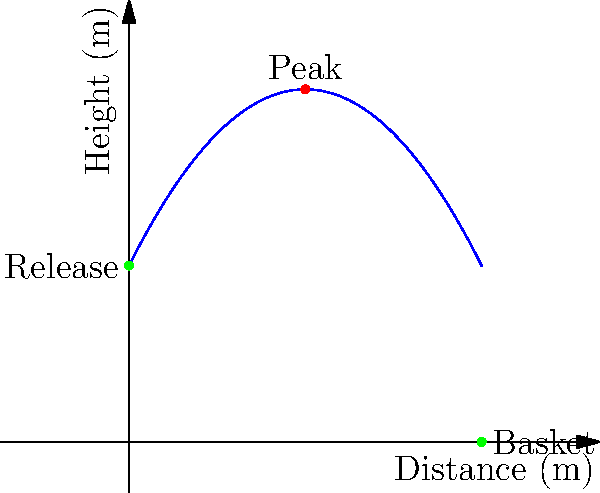As a former professional basketball player, you're analyzing the trajectory of a shot. The path of the ball can be modeled by the quadratic function $h(x) = -0.2x^2 + 2x + 5$, where $h$ is the height in meters and $x$ is the horizontal distance in meters. What is the maximum height reached by the ball during its flight? To find the maximum height of the ball's trajectory, we need to follow these steps:

1) The maximum height occurs at the vertex of the parabola. For a quadratic function in the form $f(x) = ax^2 + bx + c$, the x-coordinate of the vertex is given by $x = -\frac{b}{2a}$.

2) In our function $h(x) = -0.2x^2 + 2x + 5$, we have:
   $a = -0.2$
   $b = 2$
   $c = 5$

3) Calculate the x-coordinate of the vertex:
   $x = -\frac{b}{2a} = -\frac{2}{2(-0.2)} = -\frac{2}{-0.4} = 5$

4) To find the maximum height, we need to calculate $h(5)$:
   $h(5) = -0.2(5)^2 + 2(5) + 5$
   $= -0.2(25) + 10 + 5$
   $= -5 + 10 + 5$
   $= 10$

Therefore, the maximum height reached by the ball is 10 meters.
Answer: 10 meters 